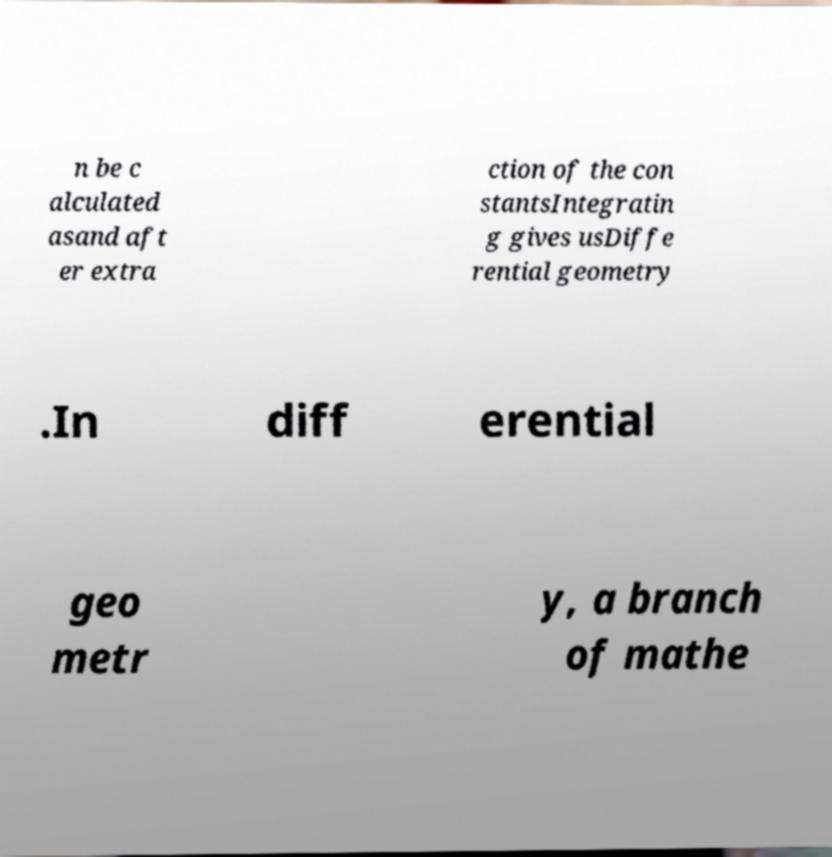Please identify and transcribe the text found in this image. n be c alculated asand aft er extra ction of the con stantsIntegratin g gives usDiffe rential geometry .In diff erential geo metr y, a branch of mathe 